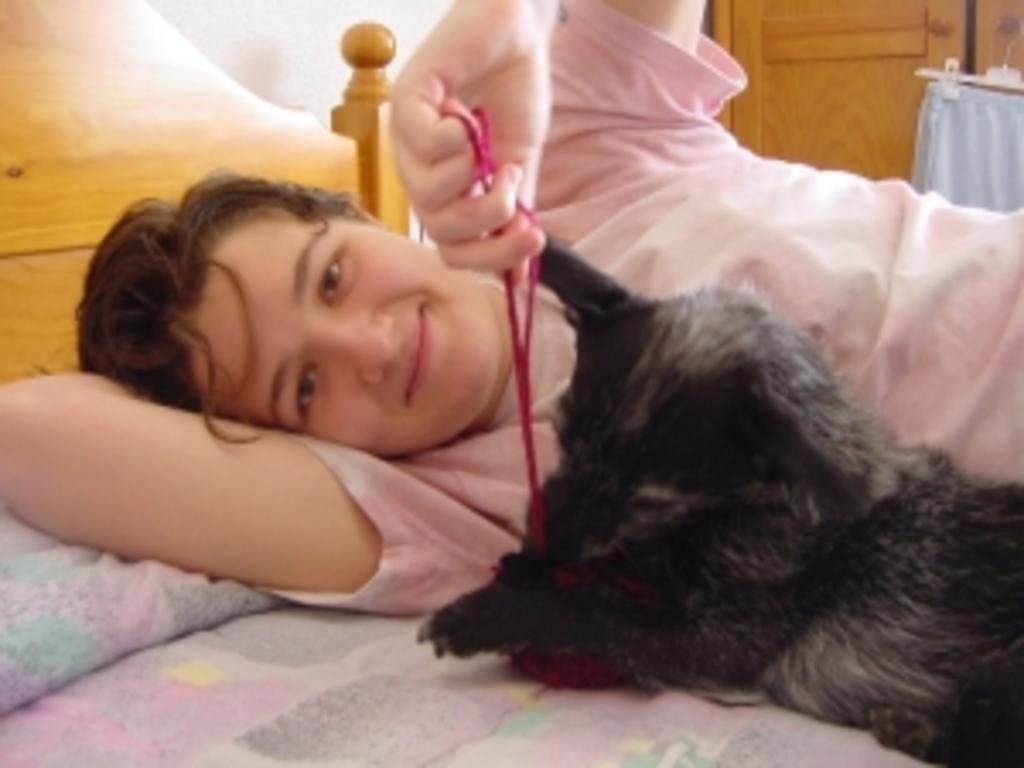Who is present in the image? There is a man in the image. What is the man doing in the image? The man is sleeping on a bed. Are there any animals present in the image? Yes, there is a pet dog in the image. What type of rings can be seen on the man's fingers in the image? There are no rings visible on the man's fingers in the image. How does the man lift the bed in the image? The man is not lifting the bed in the image; he is sleeping on it. 